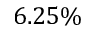<formula> <loc_0><loc_0><loc_500><loc_500>6 . 2 5 \%</formula> 